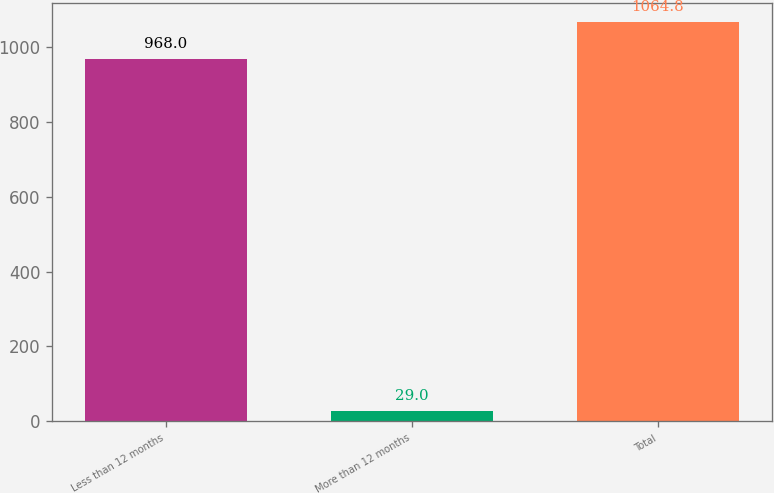<chart> <loc_0><loc_0><loc_500><loc_500><bar_chart><fcel>Less than 12 months<fcel>More than 12 months<fcel>Total<nl><fcel>968<fcel>29<fcel>1064.8<nl></chart> 